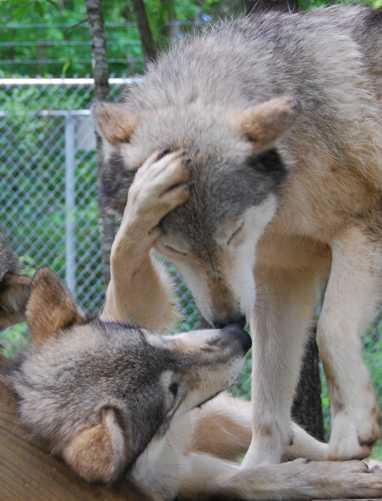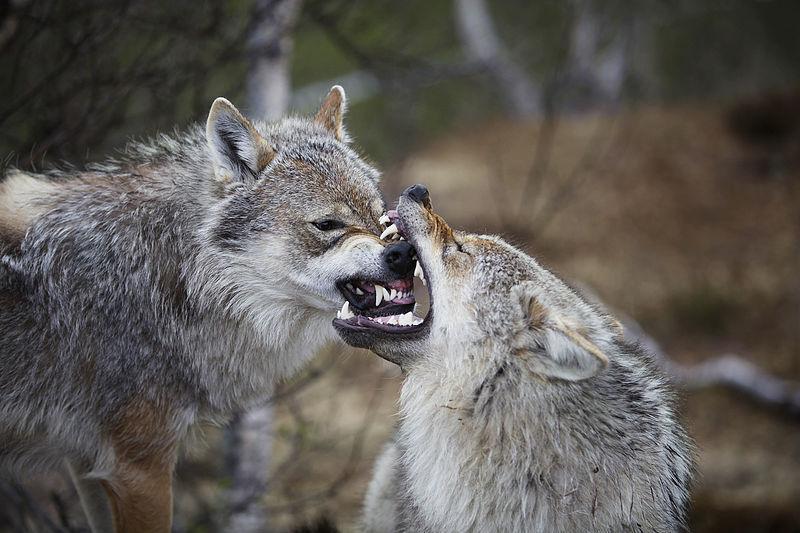The first image is the image on the left, the second image is the image on the right. Examine the images to the left and right. Is the description "All wolves are touching each other's faces in an affectionate way." accurate? Answer yes or no. No. The first image is the image on the left, the second image is the image on the right. Analyze the images presented: Is the assertion "At least one wolf has its tongue visible in the left image." valid? Answer yes or no. No. 